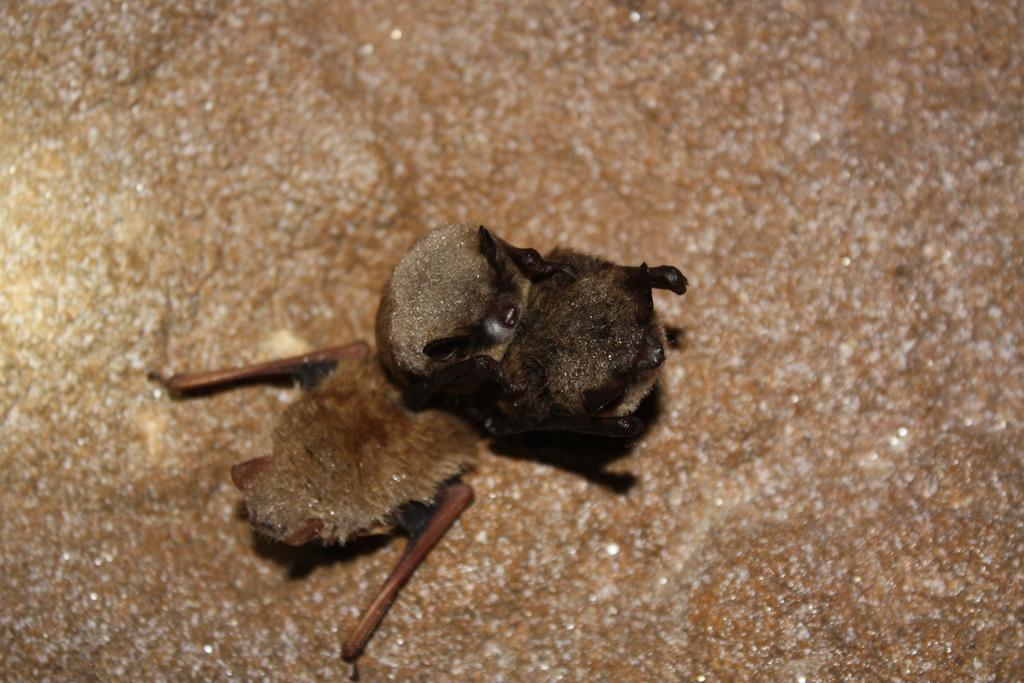Could you give a brief overview of what you see in this image? In this image we can see a bird on the surface. 